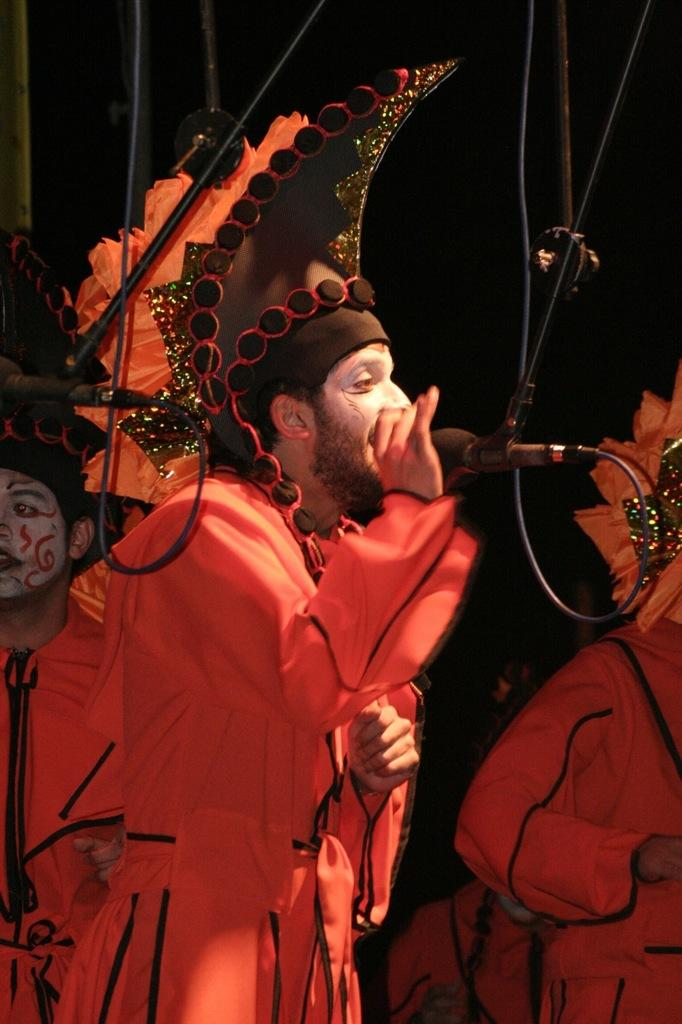What is the main subject of the image? The main subject of the image is a man. What is the man doing in the image? The man is singing a song and holding a microphone. What is the man wearing in the image? The man is wearing different costumes. Are there any other people in the image? Yes, there is another person in the image. What is the other person wearing? The other person is also wearing costumes. What is the title of the book the man is reading in the image? There is no book present in the image, and the man is singing a song, not reading a book. What type of test is the beast taking in the image? There is no beast present in the image, and the man is singing a song, not taking a test. 